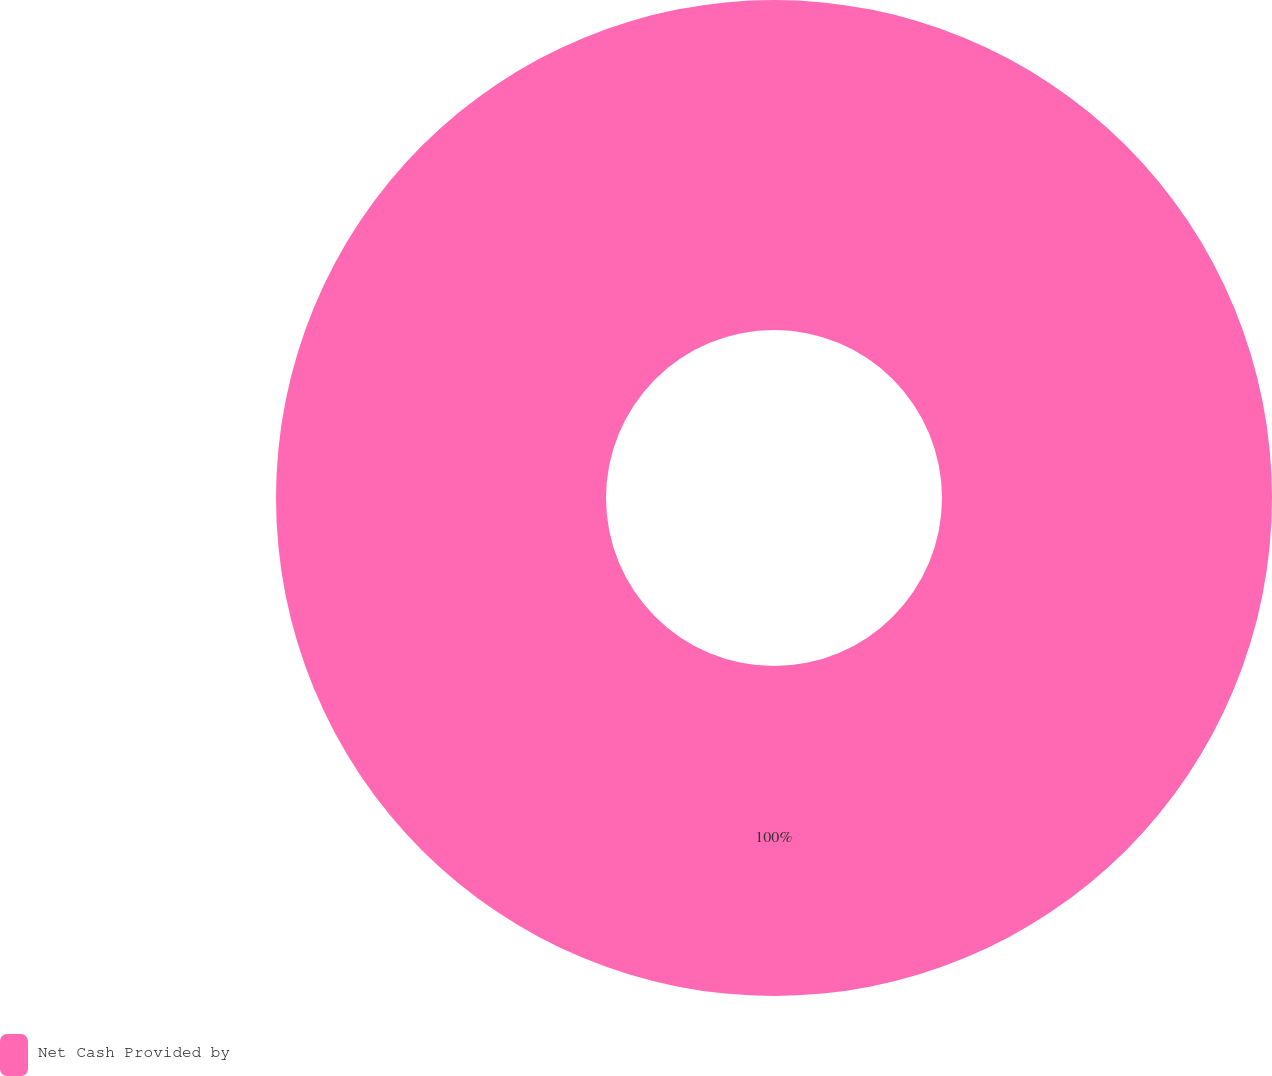<chart> <loc_0><loc_0><loc_500><loc_500><pie_chart><fcel>Net Cash Provided by<nl><fcel>100.0%<nl></chart> 